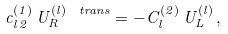<formula> <loc_0><loc_0><loc_500><loc_500>c ^ { ( 1 ) } _ { l \, 2 } \, U _ { R } ^ { ( l ) \, \ t r a n s } = - C ^ { ( 2 ) } _ { l } \, U _ { L } ^ { ( l ) } \, ,</formula> 